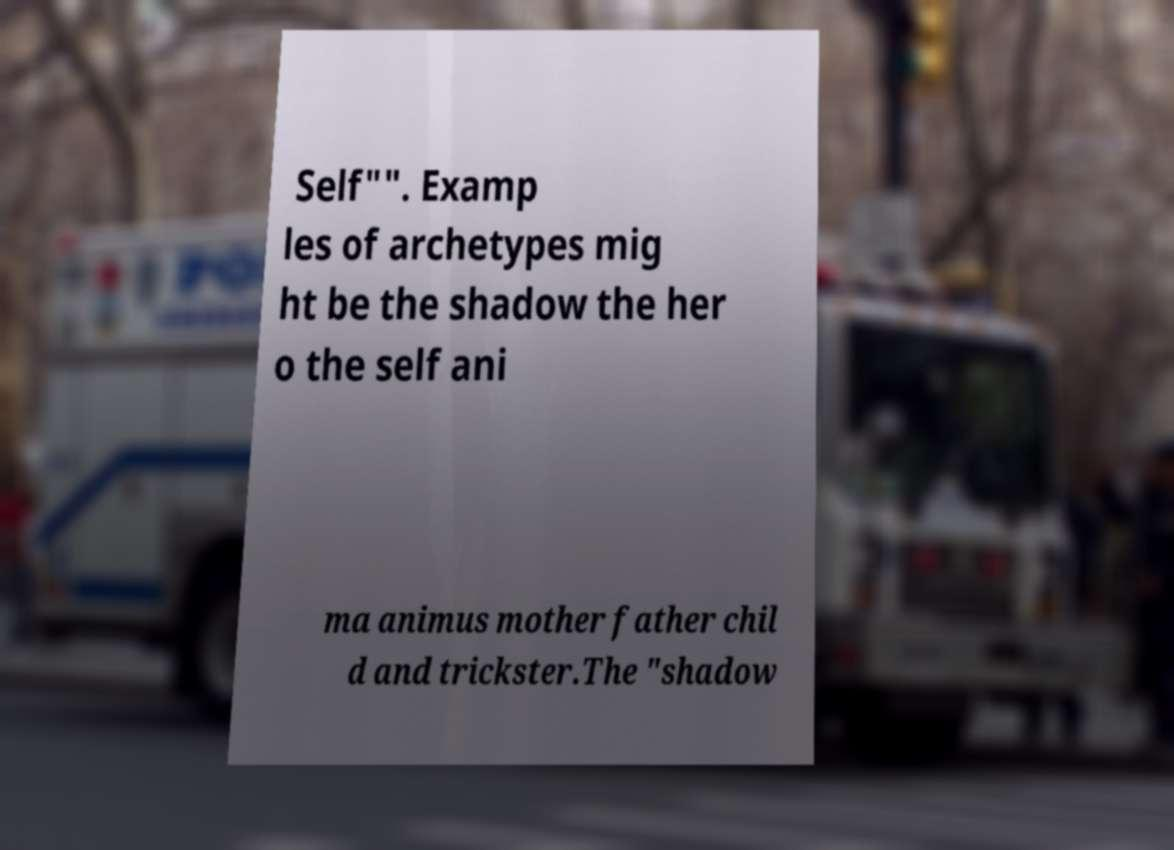Could you extract and type out the text from this image? Self"". Examp les of archetypes mig ht be the shadow the her o the self ani ma animus mother father chil d and trickster.The "shadow 